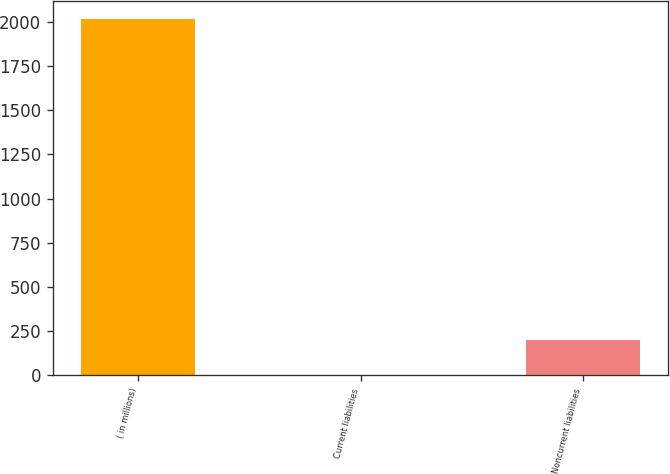<chart> <loc_0><loc_0><loc_500><loc_500><bar_chart><fcel>( in millions)<fcel>Current liabilities<fcel>Noncurrent liabilities<nl><fcel>2017<fcel>0.7<fcel>202.33<nl></chart> 